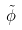Convert formula to latex. <formula><loc_0><loc_0><loc_500><loc_500>\tilde { \phi }</formula> 